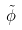Convert formula to latex. <formula><loc_0><loc_0><loc_500><loc_500>\tilde { \phi }</formula> 